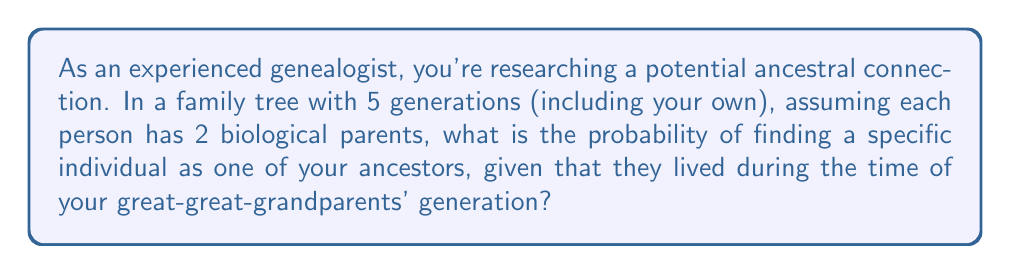Can you answer this question? Let's approach this step-by-step:

1) First, we need to calculate the total number of ancestors in the 5th generation (great-great-grandparents):
   - 1st generation (you): $2^0 = 1$
   - 2nd generation (parents): $2^1 = 2$
   - 3rd generation (grandparents): $2^2 = 4$
   - 4th generation (great-grandparents): $2^3 = 8$
   - 5th generation (great-great-grandparents): $2^4 = 16$

2) The question asks about the probability of finding a specific individual in the 5th generation.

3) In probability theory, when we're looking for a specific outcome out of all possible outcomes, and each outcome is equally likely, the probability is:

   $$ P(\text{event}) = \frac{\text{number of favorable outcomes}}{\text{total number of possible outcomes}} $$

4) In this case:
   - Number of favorable outcomes: 1 (the specific individual we're looking for)
   - Total number of possible outcomes: 16 (total number of great-great-grandparents)

5) Therefore, the probability is:

   $$ P(\text{finding specific ancestor}) = \frac{1}{16} = 0.0625 $$
Answer: $\frac{1}{16}$ or $0.0625$ or $6.25\%$ 